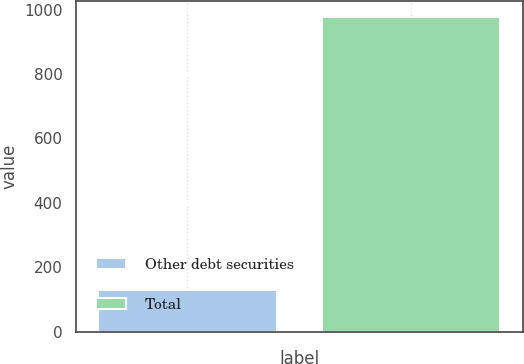Convert chart to OTSL. <chart><loc_0><loc_0><loc_500><loc_500><bar_chart><fcel>Other debt securities<fcel>Total<nl><fcel>129.2<fcel>977.4<nl></chart> 